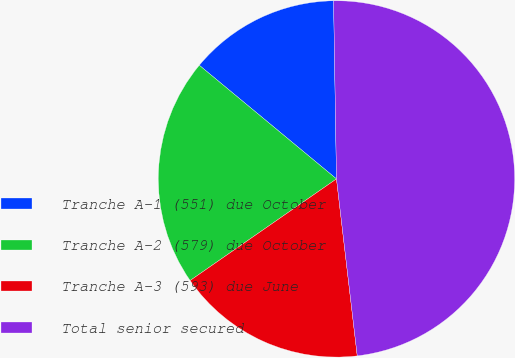Convert chart. <chart><loc_0><loc_0><loc_500><loc_500><pie_chart><fcel>Tranche A-1 (551) due October<fcel>Tranche A-2 (579) due October<fcel>Tranche A-3 (593) due June<fcel>Total senior secured<nl><fcel>13.73%<fcel>20.67%<fcel>17.2%<fcel>48.4%<nl></chart> 